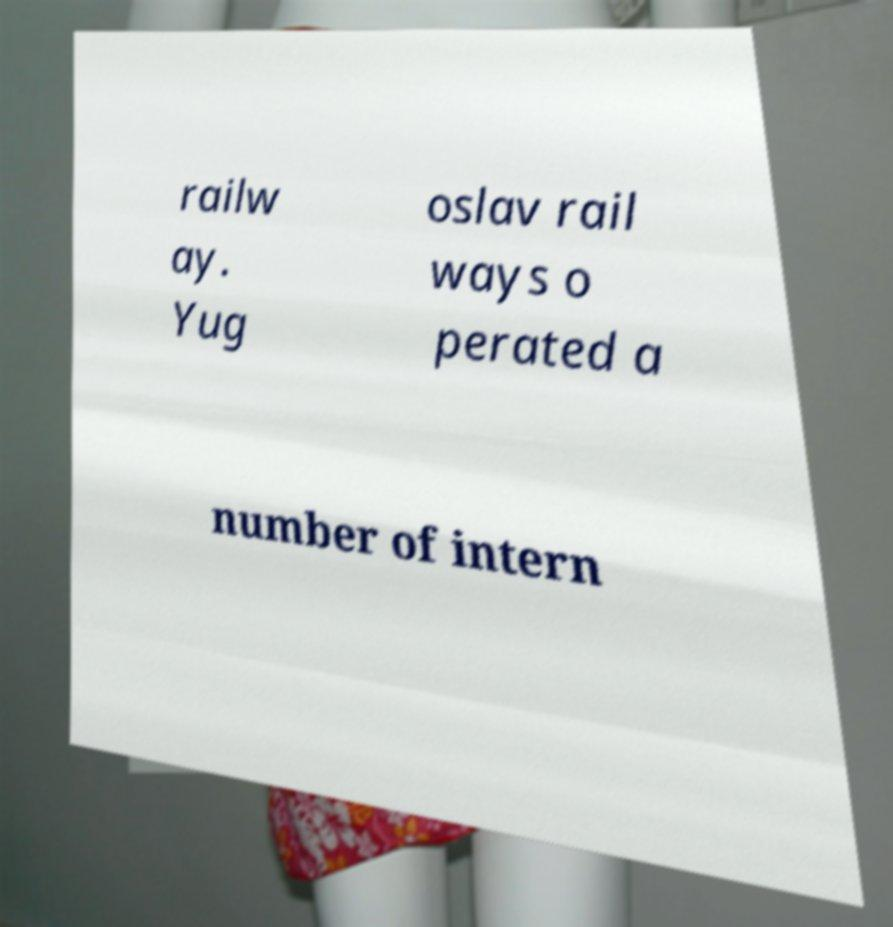For documentation purposes, I need the text within this image transcribed. Could you provide that? railw ay. Yug oslav rail ways o perated a number of intern 